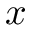<formula> <loc_0><loc_0><loc_500><loc_500>x</formula> 